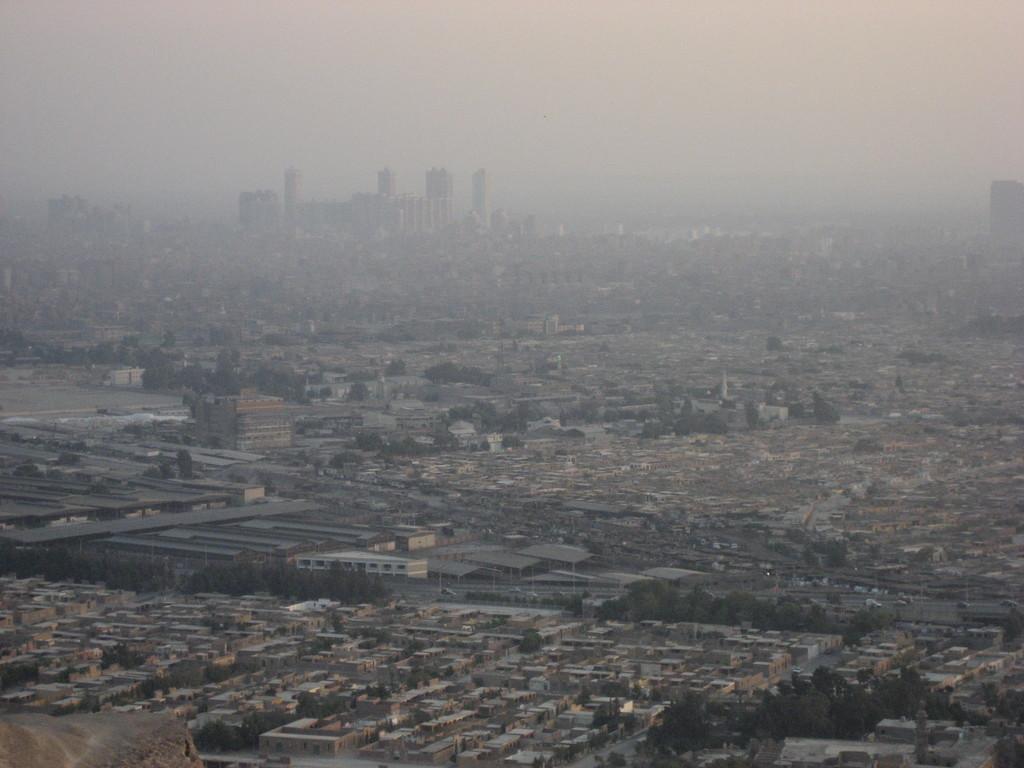In one or two sentences, can you explain what this image depicts? This is an aerial view of an image where I can see buildings, trees, frog and the plain sky in the background. 